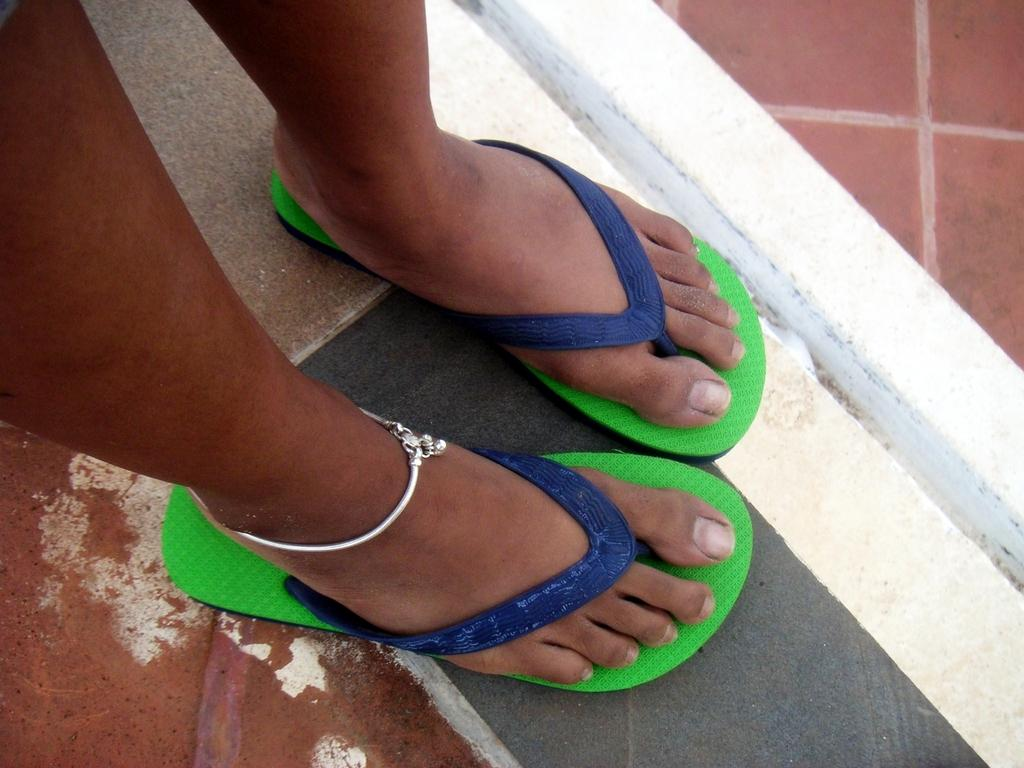Who or what is the main subject in the image? There is a person in the image. What type of footwear is the person wearing? The person is wearing slippers. Are there any accessories visible on the person? Yes, the person is wearing an anklet. What is the skin's texture like in the image? The provided facts do not mention the skin's texture, so it cannot be determined from the image. 